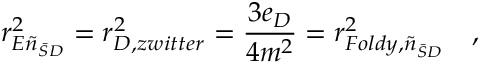Convert formula to latex. <formula><loc_0><loc_0><loc_500><loc_500>r _ { E \tilde { n } _ { \bar { S } D } } ^ { 2 } = r _ { D , z w i t t e r } ^ { 2 } = { \frac { 3 e _ { D } } { 4 m ^ { 2 } } } = r _ { F o l d y , \tilde { n } _ { \bar { S } D } } ^ { 2 } ,</formula> 